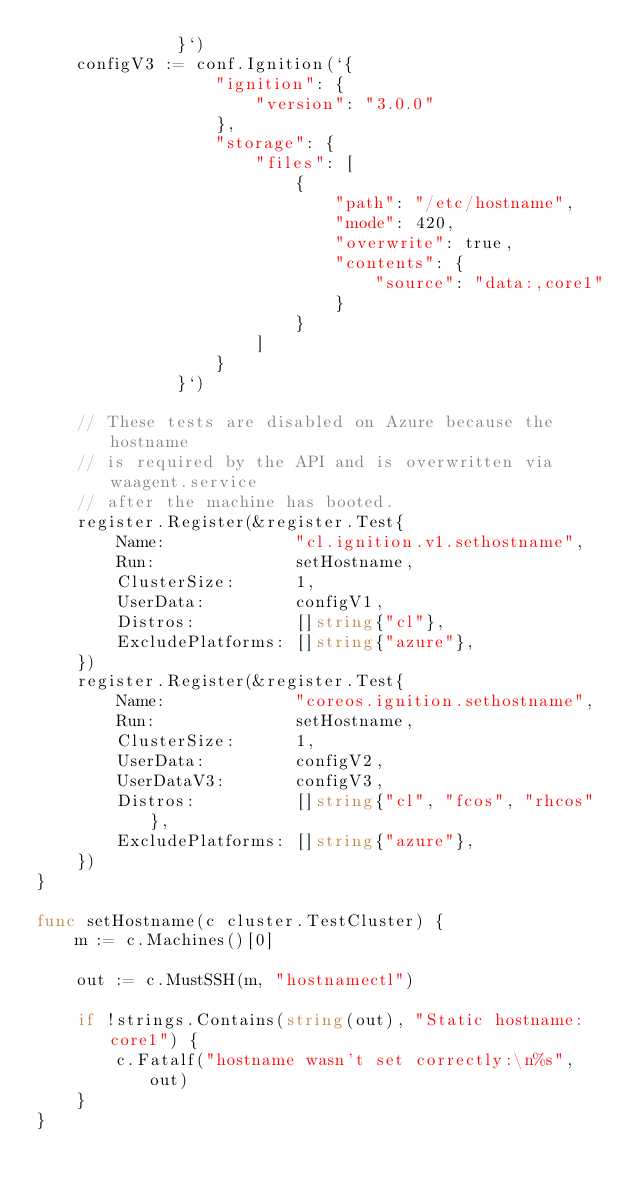<code> <loc_0><loc_0><loc_500><loc_500><_Go_>		      }`)
	configV3 := conf.Ignition(`{
		          "ignition": {
		              "version": "3.0.0"
		          },
		          "storage": {
		              "files": [
		                  {
		                      "path": "/etc/hostname",
		                      "mode": 420,
							  "overwrite": true,
		                      "contents": {
		                          "source": "data:,core1"
		                      }
		                  }
		              ]
		          }
		      }`)

	// These tests are disabled on Azure because the hostname
	// is required by the API and is overwritten via waagent.service
	// after the machine has booted.
	register.Register(&register.Test{
		Name:             "cl.ignition.v1.sethostname",
		Run:              setHostname,
		ClusterSize:      1,
		UserData:         configV1,
		Distros:          []string{"cl"},
		ExcludePlatforms: []string{"azure"},
	})
	register.Register(&register.Test{
		Name:             "coreos.ignition.sethostname",
		Run:              setHostname,
		ClusterSize:      1,
		UserData:         configV2,
		UserDataV3:       configV3,
		Distros:          []string{"cl", "fcos", "rhcos"},
		ExcludePlatforms: []string{"azure"},
	})
}

func setHostname(c cluster.TestCluster) {
	m := c.Machines()[0]

	out := c.MustSSH(m, "hostnamectl")

	if !strings.Contains(string(out), "Static hostname: core1") {
		c.Fatalf("hostname wasn't set correctly:\n%s", out)
	}
}
</code> 